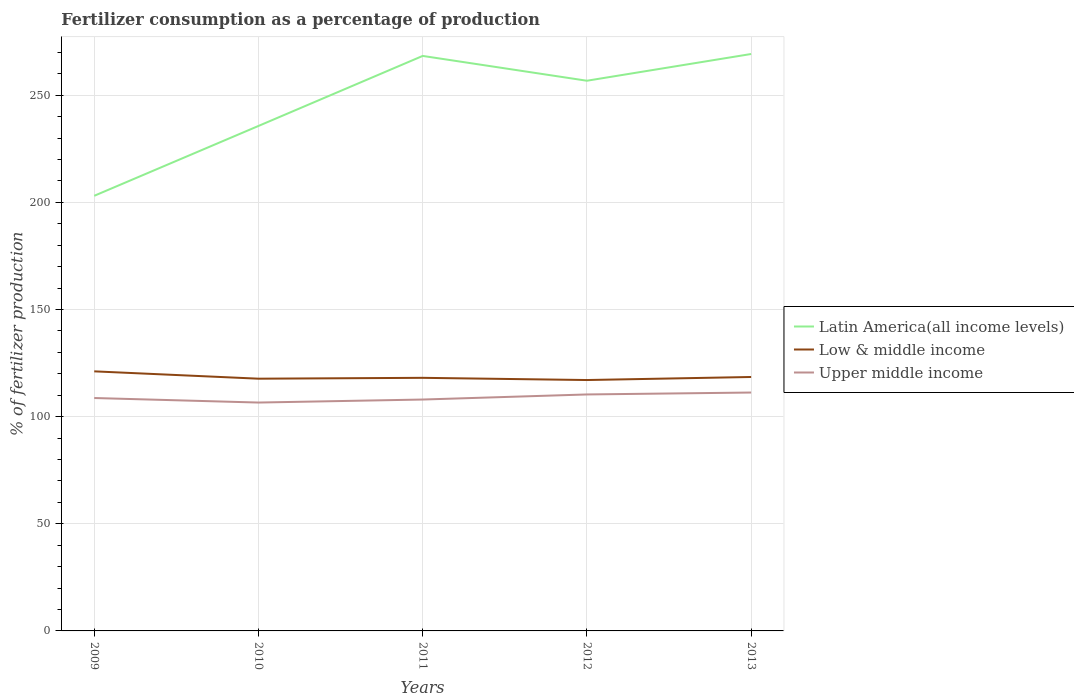Is the number of lines equal to the number of legend labels?
Provide a succinct answer. Yes. Across all years, what is the maximum percentage of fertilizers consumed in Upper middle income?
Your answer should be compact. 106.56. In which year was the percentage of fertilizers consumed in Latin America(all income levels) maximum?
Offer a very short reply. 2009. What is the total percentage of fertilizers consumed in Latin America(all income levels) in the graph?
Your answer should be compact. -33.57. What is the difference between the highest and the second highest percentage of fertilizers consumed in Upper middle income?
Keep it short and to the point. 4.68. How many years are there in the graph?
Keep it short and to the point. 5. What is the difference between two consecutive major ticks on the Y-axis?
Keep it short and to the point. 50. Does the graph contain grids?
Keep it short and to the point. Yes. What is the title of the graph?
Make the answer very short. Fertilizer consumption as a percentage of production. Does "South Asia" appear as one of the legend labels in the graph?
Ensure brevity in your answer.  No. What is the label or title of the X-axis?
Your response must be concise. Years. What is the label or title of the Y-axis?
Provide a succinct answer. % of fertilizer production. What is the % of fertilizer production of Latin America(all income levels) in 2009?
Ensure brevity in your answer.  203.04. What is the % of fertilizer production in Low & middle income in 2009?
Offer a very short reply. 121.12. What is the % of fertilizer production of Upper middle income in 2009?
Offer a terse response. 108.68. What is the % of fertilizer production in Latin America(all income levels) in 2010?
Make the answer very short. 235.63. What is the % of fertilizer production of Low & middle income in 2010?
Make the answer very short. 117.7. What is the % of fertilizer production in Upper middle income in 2010?
Keep it short and to the point. 106.56. What is the % of fertilizer production in Latin America(all income levels) in 2011?
Offer a very short reply. 268.3. What is the % of fertilizer production in Low & middle income in 2011?
Give a very brief answer. 118.1. What is the % of fertilizer production in Upper middle income in 2011?
Ensure brevity in your answer.  107.97. What is the % of fertilizer production in Latin America(all income levels) in 2012?
Provide a succinct answer. 256.73. What is the % of fertilizer production in Low & middle income in 2012?
Keep it short and to the point. 117.07. What is the % of fertilizer production of Upper middle income in 2012?
Keep it short and to the point. 110.34. What is the % of fertilizer production of Latin America(all income levels) in 2013?
Offer a very short reply. 269.2. What is the % of fertilizer production of Low & middle income in 2013?
Ensure brevity in your answer.  118.49. What is the % of fertilizer production in Upper middle income in 2013?
Offer a terse response. 111.24. Across all years, what is the maximum % of fertilizer production of Latin America(all income levels)?
Provide a succinct answer. 269.2. Across all years, what is the maximum % of fertilizer production in Low & middle income?
Keep it short and to the point. 121.12. Across all years, what is the maximum % of fertilizer production in Upper middle income?
Make the answer very short. 111.24. Across all years, what is the minimum % of fertilizer production of Latin America(all income levels)?
Ensure brevity in your answer.  203.04. Across all years, what is the minimum % of fertilizer production in Low & middle income?
Offer a terse response. 117.07. Across all years, what is the minimum % of fertilizer production in Upper middle income?
Your response must be concise. 106.56. What is the total % of fertilizer production in Latin America(all income levels) in the graph?
Keep it short and to the point. 1232.9. What is the total % of fertilizer production in Low & middle income in the graph?
Offer a terse response. 592.48. What is the total % of fertilizer production in Upper middle income in the graph?
Provide a succinct answer. 544.79. What is the difference between the % of fertilizer production of Latin America(all income levels) in 2009 and that in 2010?
Ensure brevity in your answer.  -32.59. What is the difference between the % of fertilizer production in Low & middle income in 2009 and that in 2010?
Your answer should be very brief. 3.42. What is the difference between the % of fertilizer production of Upper middle income in 2009 and that in 2010?
Keep it short and to the point. 2.12. What is the difference between the % of fertilizer production in Latin America(all income levels) in 2009 and that in 2011?
Make the answer very short. -65.27. What is the difference between the % of fertilizer production in Low & middle income in 2009 and that in 2011?
Offer a very short reply. 3.02. What is the difference between the % of fertilizer production in Upper middle income in 2009 and that in 2011?
Offer a terse response. 0.71. What is the difference between the % of fertilizer production of Latin America(all income levels) in 2009 and that in 2012?
Ensure brevity in your answer.  -53.69. What is the difference between the % of fertilizer production of Low & middle income in 2009 and that in 2012?
Your answer should be compact. 4.05. What is the difference between the % of fertilizer production in Upper middle income in 2009 and that in 2012?
Offer a terse response. -1.66. What is the difference between the % of fertilizer production in Latin America(all income levels) in 2009 and that in 2013?
Keep it short and to the point. -66.16. What is the difference between the % of fertilizer production of Low & middle income in 2009 and that in 2013?
Provide a succinct answer. 2.63. What is the difference between the % of fertilizer production of Upper middle income in 2009 and that in 2013?
Provide a short and direct response. -2.56. What is the difference between the % of fertilizer production in Latin America(all income levels) in 2010 and that in 2011?
Ensure brevity in your answer.  -32.68. What is the difference between the % of fertilizer production of Low & middle income in 2010 and that in 2011?
Provide a succinct answer. -0.4. What is the difference between the % of fertilizer production in Upper middle income in 2010 and that in 2011?
Ensure brevity in your answer.  -1.41. What is the difference between the % of fertilizer production in Latin America(all income levels) in 2010 and that in 2012?
Give a very brief answer. -21.1. What is the difference between the % of fertilizer production in Low & middle income in 2010 and that in 2012?
Make the answer very short. 0.63. What is the difference between the % of fertilizer production of Upper middle income in 2010 and that in 2012?
Your answer should be very brief. -3.78. What is the difference between the % of fertilizer production in Latin America(all income levels) in 2010 and that in 2013?
Make the answer very short. -33.57. What is the difference between the % of fertilizer production of Low & middle income in 2010 and that in 2013?
Make the answer very short. -0.79. What is the difference between the % of fertilizer production of Upper middle income in 2010 and that in 2013?
Your answer should be very brief. -4.68. What is the difference between the % of fertilizer production of Latin America(all income levels) in 2011 and that in 2012?
Keep it short and to the point. 11.58. What is the difference between the % of fertilizer production of Low & middle income in 2011 and that in 2012?
Provide a succinct answer. 1.02. What is the difference between the % of fertilizer production of Upper middle income in 2011 and that in 2012?
Your answer should be very brief. -2.37. What is the difference between the % of fertilizer production in Latin America(all income levels) in 2011 and that in 2013?
Ensure brevity in your answer.  -0.9. What is the difference between the % of fertilizer production of Low & middle income in 2011 and that in 2013?
Keep it short and to the point. -0.39. What is the difference between the % of fertilizer production in Upper middle income in 2011 and that in 2013?
Give a very brief answer. -3.27. What is the difference between the % of fertilizer production of Latin America(all income levels) in 2012 and that in 2013?
Offer a terse response. -12.47. What is the difference between the % of fertilizer production in Low & middle income in 2012 and that in 2013?
Ensure brevity in your answer.  -1.42. What is the difference between the % of fertilizer production of Upper middle income in 2012 and that in 2013?
Offer a very short reply. -0.89. What is the difference between the % of fertilizer production of Latin America(all income levels) in 2009 and the % of fertilizer production of Low & middle income in 2010?
Your answer should be compact. 85.34. What is the difference between the % of fertilizer production of Latin America(all income levels) in 2009 and the % of fertilizer production of Upper middle income in 2010?
Your response must be concise. 96.48. What is the difference between the % of fertilizer production of Low & middle income in 2009 and the % of fertilizer production of Upper middle income in 2010?
Your response must be concise. 14.56. What is the difference between the % of fertilizer production in Latin America(all income levels) in 2009 and the % of fertilizer production in Low & middle income in 2011?
Your answer should be compact. 84.94. What is the difference between the % of fertilizer production in Latin America(all income levels) in 2009 and the % of fertilizer production in Upper middle income in 2011?
Your answer should be compact. 95.07. What is the difference between the % of fertilizer production in Low & middle income in 2009 and the % of fertilizer production in Upper middle income in 2011?
Your answer should be very brief. 13.15. What is the difference between the % of fertilizer production in Latin America(all income levels) in 2009 and the % of fertilizer production in Low & middle income in 2012?
Provide a short and direct response. 85.97. What is the difference between the % of fertilizer production of Latin America(all income levels) in 2009 and the % of fertilizer production of Upper middle income in 2012?
Give a very brief answer. 92.69. What is the difference between the % of fertilizer production in Low & middle income in 2009 and the % of fertilizer production in Upper middle income in 2012?
Your response must be concise. 10.78. What is the difference between the % of fertilizer production in Latin America(all income levels) in 2009 and the % of fertilizer production in Low & middle income in 2013?
Offer a terse response. 84.55. What is the difference between the % of fertilizer production of Latin America(all income levels) in 2009 and the % of fertilizer production of Upper middle income in 2013?
Offer a terse response. 91.8. What is the difference between the % of fertilizer production in Low & middle income in 2009 and the % of fertilizer production in Upper middle income in 2013?
Make the answer very short. 9.88. What is the difference between the % of fertilizer production of Latin America(all income levels) in 2010 and the % of fertilizer production of Low & middle income in 2011?
Offer a terse response. 117.53. What is the difference between the % of fertilizer production in Latin America(all income levels) in 2010 and the % of fertilizer production in Upper middle income in 2011?
Make the answer very short. 127.66. What is the difference between the % of fertilizer production in Low & middle income in 2010 and the % of fertilizer production in Upper middle income in 2011?
Keep it short and to the point. 9.73. What is the difference between the % of fertilizer production of Latin America(all income levels) in 2010 and the % of fertilizer production of Low & middle income in 2012?
Provide a succinct answer. 118.56. What is the difference between the % of fertilizer production in Latin America(all income levels) in 2010 and the % of fertilizer production in Upper middle income in 2012?
Provide a succinct answer. 125.29. What is the difference between the % of fertilizer production of Low & middle income in 2010 and the % of fertilizer production of Upper middle income in 2012?
Make the answer very short. 7.36. What is the difference between the % of fertilizer production in Latin America(all income levels) in 2010 and the % of fertilizer production in Low & middle income in 2013?
Your answer should be very brief. 117.14. What is the difference between the % of fertilizer production in Latin America(all income levels) in 2010 and the % of fertilizer production in Upper middle income in 2013?
Offer a terse response. 124.39. What is the difference between the % of fertilizer production in Low & middle income in 2010 and the % of fertilizer production in Upper middle income in 2013?
Offer a terse response. 6.46. What is the difference between the % of fertilizer production of Latin America(all income levels) in 2011 and the % of fertilizer production of Low & middle income in 2012?
Ensure brevity in your answer.  151.23. What is the difference between the % of fertilizer production of Latin America(all income levels) in 2011 and the % of fertilizer production of Upper middle income in 2012?
Provide a succinct answer. 157.96. What is the difference between the % of fertilizer production of Low & middle income in 2011 and the % of fertilizer production of Upper middle income in 2012?
Your response must be concise. 7.75. What is the difference between the % of fertilizer production of Latin America(all income levels) in 2011 and the % of fertilizer production of Low & middle income in 2013?
Give a very brief answer. 149.82. What is the difference between the % of fertilizer production of Latin America(all income levels) in 2011 and the % of fertilizer production of Upper middle income in 2013?
Offer a terse response. 157.07. What is the difference between the % of fertilizer production of Low & middle income in 2011 and the % of fertilizer production of Upper middle income in 2013?
Provide a succinct answer. 6.86. What is the difference between the % of fertilizer production of Latin America(all income levels) in 2012 and the % of fertilizer production of Low & middle income in 2013?
Provide a short and direct response. 138.24. What is the difference between the % of fertilizer production in Latin America(all income levels) in 2012 and the % of fertilizer production in Upper middle income in 2013?
Your answer should be compact. 145.49. What is the difference between the % of fertilizer production of Low & middle income in 2012 and the % of fertilizer production of Upper middle income in 2013?
Give a very brief answer. 5.84. What is the average % of fertilizer production in Latin America(all income levels) per year?
Offer a terse response. 246.58. What is the average % of fertilizer production in Low & middle income per year?
Provide a succinct answer. 118.5. What is the average % of fertilizer production in Upper middle income per year?
Your response must be concise. 108.96. In the year 2009, what is the difference between the % of fertilizer production of Latin America(all income levels) and % of fertilizer production of Low & middle income?
Your response must be concise. 81.92. In the year 2009, what is the difference between the % of fertilizer production of Latin America(all income levels) and % of fertilizer production of Upper middle income?
Make the answer very short. 94.36. In the year 2009, what is the difference between the % of fertilizer production in Low & middle income and % of fertilizer production in Upper middle income?
Provide a succinct answer. 12.44. In the year 2010, what is the difference between the % of fertilizer production in Latin America(all income levels) and % of fertilizer production in Low & middle income?
Offer a very short reply. 117.93. In the year 2010, what is the difference between the % of fertilizer production of Latin America(all income levels) and % of fertilizer production of Upper middle income?
Offer a terse response. 129.07. In the year 2010, what is the difference between the % of fertilizer production in Low & middle income and % of fertilizer production in Upper middle income?
Keep it short and to the point. 11.14. In the year 2011, what is the difference between the % of fertilizer production in Latin America(all income levels) and % of fertilizer production in Low & middle income?
Make the answer very short. 150.21. In the year 2011, what is the difference between the % of fertilizer production in Latin America(all income levels) and % of fertilizer production in Upper middle income?
Keep it short and to the point. 160.34. In the year 2011, what is the difference between the % of fertilizer production of Low & middle income and % of fertilizer production of Upper middle income?
Your response must be concise. 10.13. In the year 2012, what is the difference between the % of fertilizer production of Latin America(all income levels) and % of fertilizer production of Low & middle income?
Offer a very short reply. 139.66. In the year 2012, what is the difference between the % of fertilizer production of Latin America(all income levels) and % of fertilizer production of Upper middle income?
Offer a terse response. 146.38. In the year 2012, what is the difference between the % of fertilizer production in Low & middle income and % of fertilizer production in Upper middle income?
Your answer should be compact. 6.73. In the year 2013, what is the difference between the % of fertilizer production of Latin America(all income levels) and % of fertilizer production of Low & middle income?
Your answer should be compact. 150.71. In the year 2013, what is the difference between the % of fertilizer production in Latin America(all income levels) and % of fertilizer production in Upper middle income?
Provide a short and direct response. 157.96. In the year 2013, what is the difference between the % of fertilizer production of Low & middle income and % of fertilizer production of Upper middle income?
Offer a very short reply. 7.25. What is the ratio of the % of fertilizer production of Latin America(all income levels) in 2009 to that in 2010?
Offer a very short reply. 0.86. What is the ratio of the % of fertilizer production of Low & middle income in 2009 to that in 2010?
Offer a terse response. 1.03. What is the ratio of the % of fertilizer production of Upper middle income in 2009 to that in 2010?
Offer a terse response. 1.02. What is the ratio of the % of fertilizer production in Latin America(all income levels) in 2009 to that in 2011?
Offer a terse response. 0.76. What is the ratio of the % of fertilizer production of Low & middle income in 2009 to that in 2011?
Provide a short and direct response. 1.03. What is the ratio of the % of fertilizer production in Upper middle income in 2009 to that in 2011?
Offer a terse response. 1.01. What is the ratio of the % of fertilizer production of Latin America(all income levels) in 2009 to that in 2012?
Offer a very short reply. 0.79. What is the ratio of the % of fertilizer production in Low & middle income in 2009 to that in 2012?
Your answer should be compact. 1.03. What is the ratio of the % of fertilizer production of Upper middle income in 2009 to that in 2012?
Offer a terse response. 0.98. What is the ratio of the % of fertilizer production in Latin America(all income levels) in 2009 to that in 2013?
Make the answer very short. 0.75. What is the ratio of the % of fertilizer production of Low & middle income in 2009 to that in 2013?
Provide a succinct answer. 1.02. What is the ratio of the % of fertilizer production in Latin America(all income levels) in 2010 to that in 2011?
Give a very brief answer. 0.88. What is the ratio of the % of fertilizer production of Latin America(all income levels) in 2010 to that in 2012?
Make the answer very short. 0.92. What is the ratio of the % of fertilizer production in Low & middle income in 2010 to that in 2012?
Your response must be concise. 1.01. What is the ratio of the % of fertilizer production in Upper middle income in 2010 to that in 2012?
Keep it short and to the point. 0.97. What is the ratio of the % of fertilizer production in Latin America(all income levels) in 2010 to that in 2013?
Give a very brief answer. 0.88. What is the ratio of the % of fertilizer production in Low & middle income in 2010 to that in 2013?
Give a very brief answer. 0.99. What is the ratio of the % of fertilizer production of Upper middle income in 2010 to that in 2013?
Offer a very short reply. 0.96. What is the ratio of the % of fertilizer production in Latin America(all income levels) in 2011 to that in 2012?
Offer a very short reply. 1.05. What is the ratio of the % of fertilizer production of Low & middle income in 2011 to that in 2012?
Offer a very short reply. 1.01. What is the ratio of the % of fertilizer production of Upper middle income in 2011 to that in 2012?
Ensure brevity in your answer.  0.98. What is the ratio of the % of fertilizer production of Latin America(all income levels) in 2011 to that in 2013?
Make the answer very short. 1. What is the ratio of the % of fertilizer production in Upper middle income in 2011 to that in 2013?
Keep it short and to the point. 0.97. What is the ratio of the % of fertilizer production of Latin America(all income levels) in 2012 to that in 2013?
Provide a succinct answer. 0.95. What is the ratio of the % of fertilizer production in Low & middle income in 2012 to that in 2013?
Your response must be concise. 0.99. What is the difference between the highest and the second highest % of fertilizer production in Latin America(all income levels)?
Your response must be concise. 0.9. What is the difference between the highest and the second highest % of fertilizer production in Low & middle income?
Your answer should be very brief. 2.63. What is the difference between the highest and the second highest % of fertilizer production in Upper middle income?
Provide a succinct answer. 0.89. What is the difference between the highest and the lowest % of fertilizer production in Latin America(all income levels)?
Offer a terse response. 66.16. What is the difference between the highest and the lowest % of fertilizer production of Low & middle income?
Offer a terse response. 4.05. What is the difference between the highest and the lowest % of fertilizer production in Upper middle income?
Your response must be concise. 4.68. 